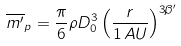<formula> <loc_0><loc_0><loc_500><loc_500>\overline { m ^ { \prime } } _ { p } = \frac { \pi } { 6 } \rho D _ { 0 } ^ { 3 } \left ( \frac { r } { 1 \, A U } \right ) ^ { 3 \beta ^ { \prime } }</formula> 